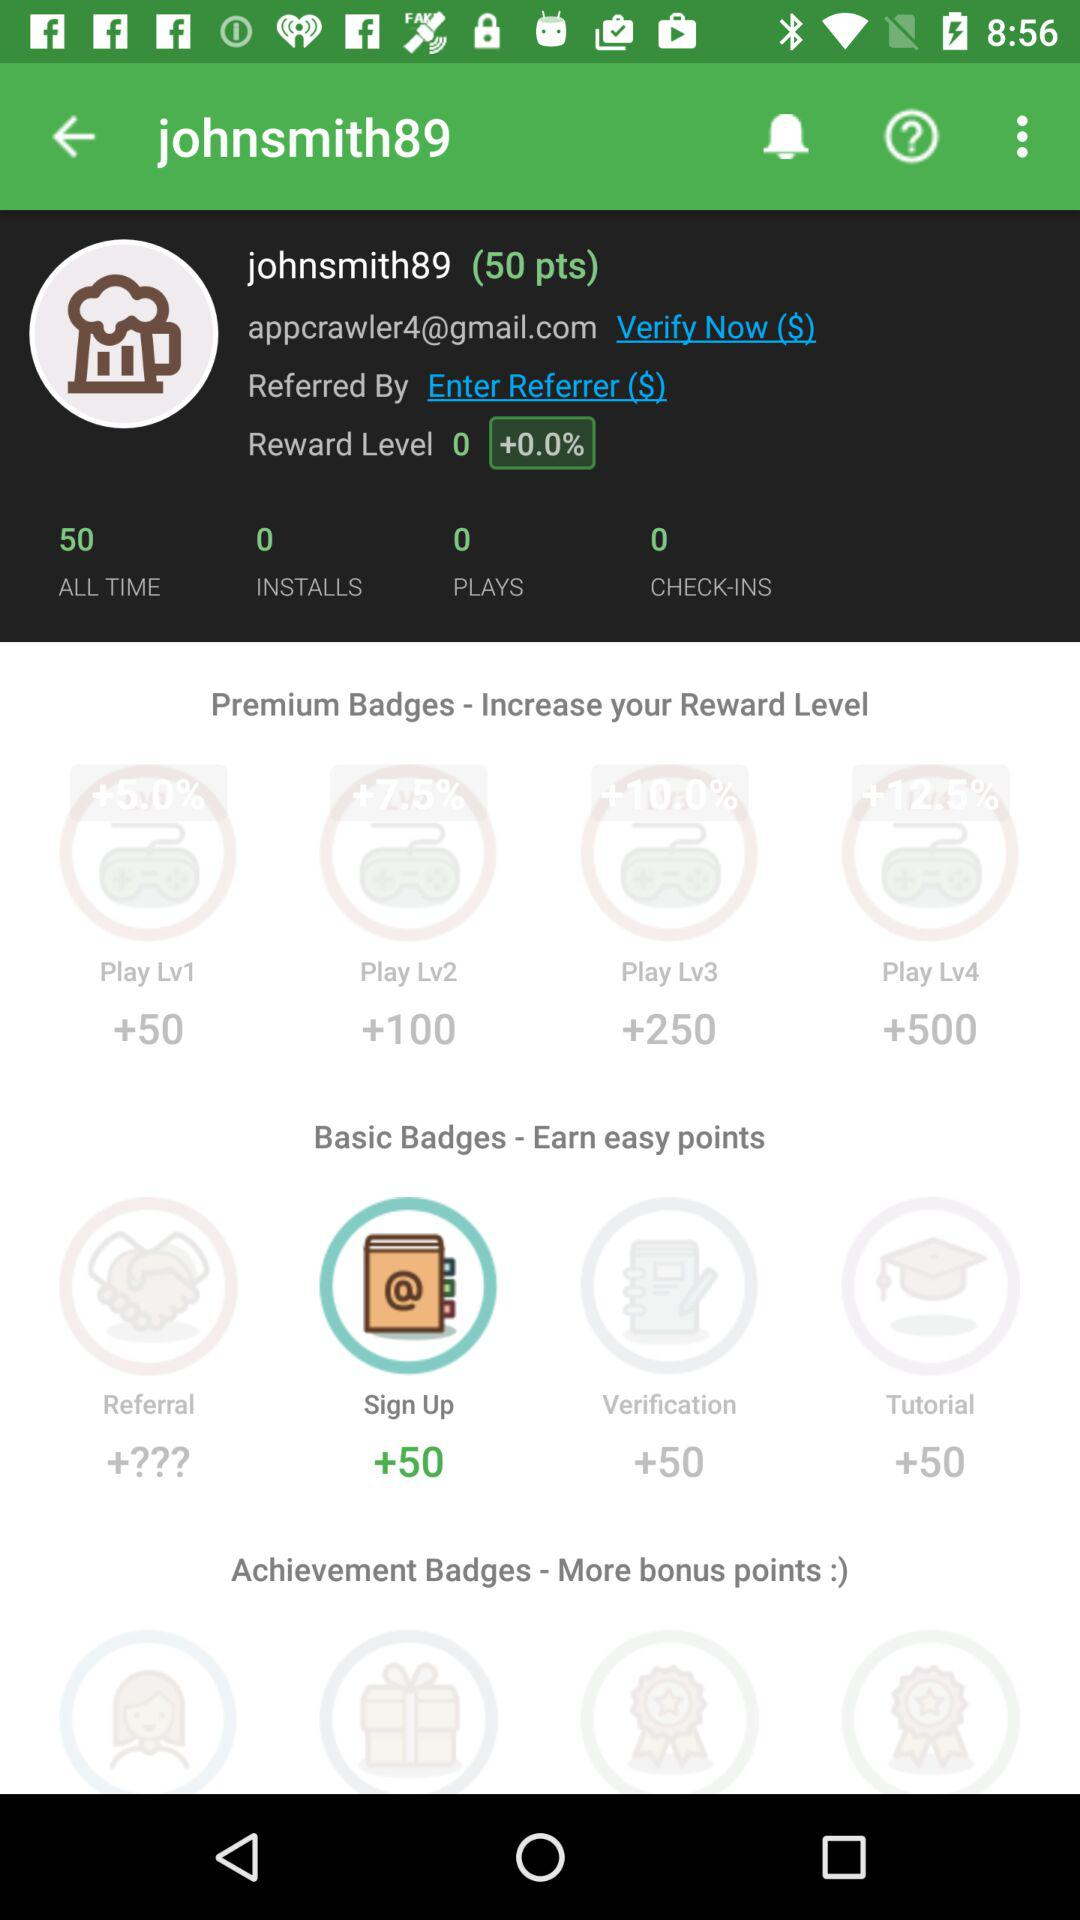How many points will be earned for signing up? The points earned for signing up are +50. 